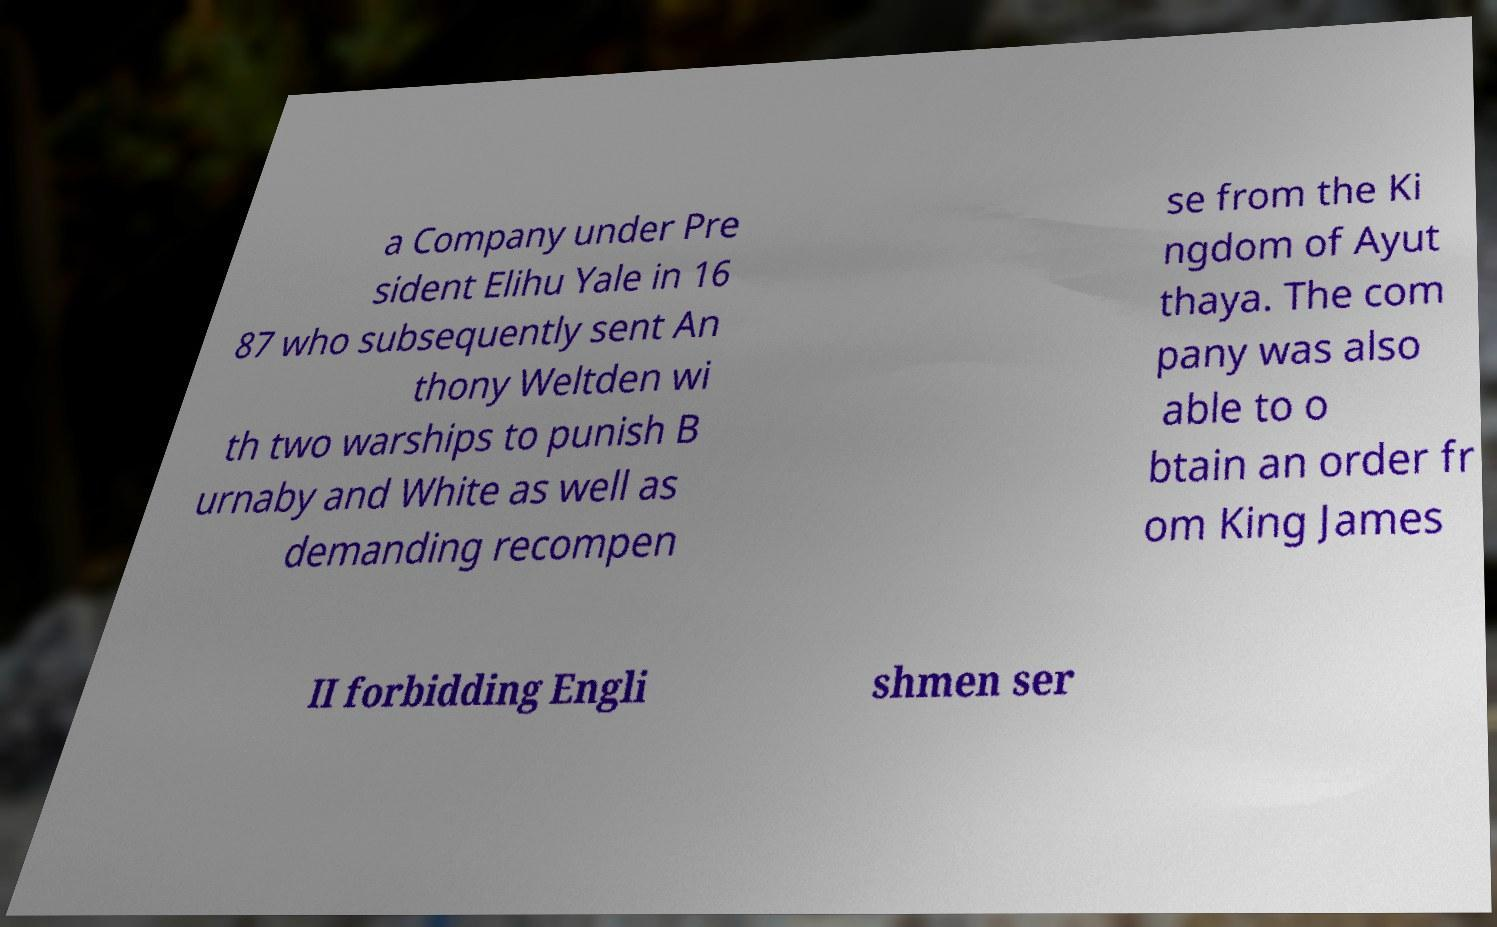I need the written content from this picture converted into text. Can you do that? a Company under Pre sident Elihu Yale in 16 87 who subsequently sent An thony Weltden wi th two warships to punish B urnaby and White as well as demanding recompen se from the Ki ngdom of Ayut thaya. The com pany was also able to o btain an order fr om King James II forbidding Engli shmen ser 